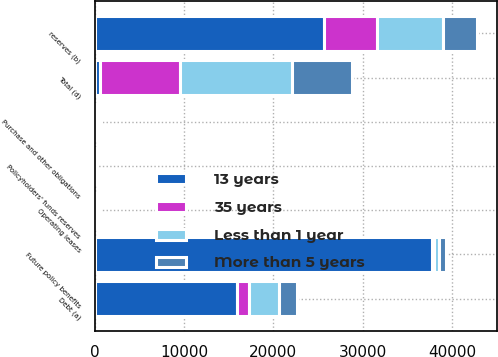Convert chart. <chart><loc_0><loc_0><loc_500><loc_500><stacked_bar_chart><ecel><fcel>Debt (a)<fcel>Operating leases<fcel>reserves (b)<fcel>Future policy benefits<fcel>Policyholders' funds reserves<fcel>Purchase and other obligations<fcel>Total (d)<nl><fcel>13 years<fcel>15912<fcel>383<fcel>25630<fcel>37749<fcel>86<fcel>343<fcel>583<nl><fcel>35 years<fcel>1379<fcel>66<fcel>5939<fcel>205<fcel>30<fcel>135<fcel>9008<nl><fcel>Less than 1 year<fcel>3335<fcel>113<fcel>7458<fcel>583<fcel>5<fcel>180<fcel>12509<nl><fcel>More than 5 years<fcel>2008<fcel>77<fcel>3816<fcel>826<fcel>1<fcel>17<fcel>6743<nl></chart> 